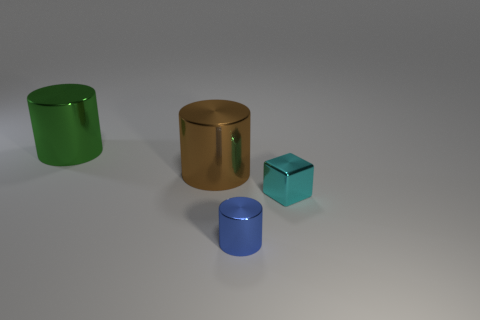What number of big green things have the same material as the brown cylinder?
Your response must be concise. 1. What is the size of the blue thing that is the same shape as the brown metallic thing?
Offer a terse response. Small. There is a blue cylinder; are there any small shiny things to the right of it?
Offer a terse response. Yes. Is there anything else that has the same shape as the small cyan object?
Your answer should be very brief. No. There is another big metallic object that is the same shape as the green shiny object; what color is it?
Your response must be concise. Brown. There is a small cylinder that is in front of the green metal cylinder; what material is it?
Keep it short and to the point. Metal. What is the color of the tiny cylinder?
Your answer should be very brief. Blue. Is the size of the metallic object that is behind the brown cylinder the same as the large brown metallic cylinder?
Make the answer very short. Yes. There is a object that is to the right of the thing that is in front of the small cyan metal cube; what is it made of?
Your response must be concise. Metal. The other thing that is the same size as the brown thing is what color?
Keep it short and to the point. Green. 